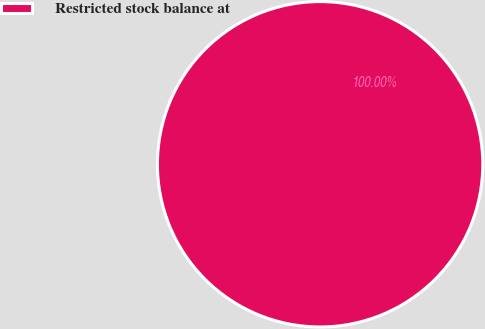Convert chart. <chart><loc_0><loc_0><loc_500><loc_500><pie_chart><fcel>Restricted stock balance at<nl><fcel>100.0%<nl></chart> 